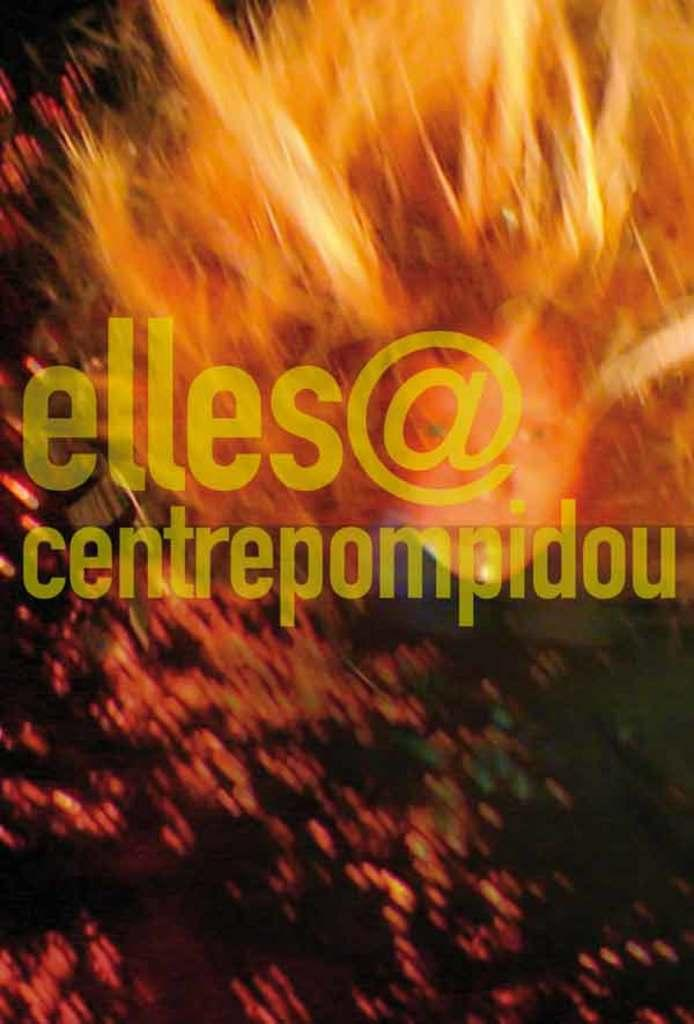Provide a one-sentence caption for the provided image. An abstract poster with a fiery look contains an email address for elles. 